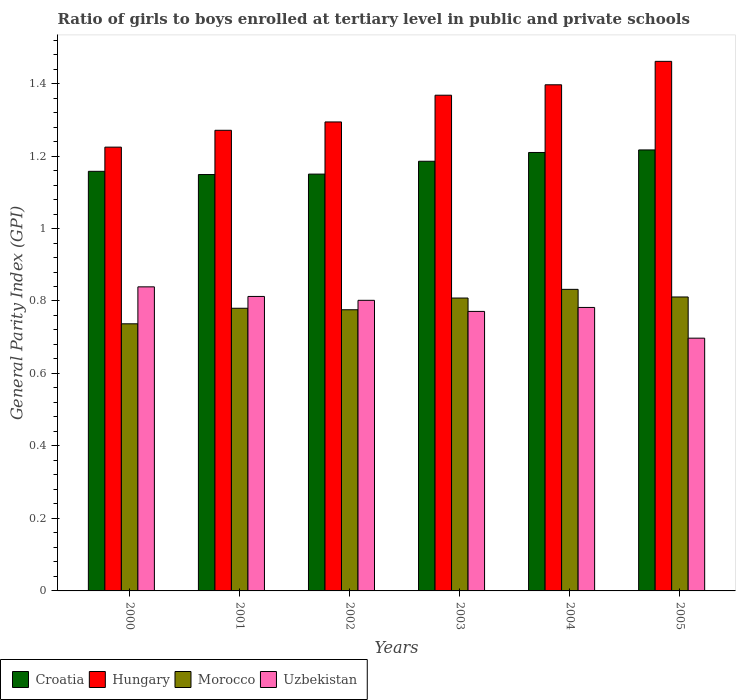How many different coloured bars are there?
Keep it short and to the point. 4. Are the number of bars per tick equal to the number of legend labels?
Ensure brevity in your answer.  Yes. Are the number of bars on each tick of the X-axis equal?
Give a very brief answer. Yes. How many bars are there on the 3rd tick from the left?
Your answer should be compact. 4. What is the label of the 2nd group of bars from the left?
Your response must be concise. 2001. In how many cases, is the number of bars for a given year not equal to the number of legend labels?
Your answer should be compact. 0. What is the general parity index in Croatia in 2002?
Keep it short and to the point. 1.15. Across all years, what is the maximum general parity index in Croatia?
Provide a short and direct response. 1.22. Across all years, what is the minimum general parity index in Uzbekistan?
Your response must be concise. 0.7. What is the total general parity index in Uzbekistan in the graph?
Keep it short and to the point. 4.7. What is the difference between the general parity index in Croatia in 2000 and that in 2003?
Your answer should be compact. -0.03. What is the difference between the general parity index in Hungary in 2000 and the general parity index in Croatia in 2003?
Give a very brief answer. 0.04. What is the average general parity index in Hungary per year?
Make the answer very short. 1.34. In the year 2003, what is the difference between the general parity index in Morocco and general parity index in Uzbekistan?
Provide a succinct answer. 0.04. What is the ratio of the general parity index in Croatia in 2001 to that in 2005?
Give a very brief answer. 0.94. Is the general parity index in Hungary in 2000 less than that in 2002?
Your answer should be very brief. Yes. What is the difference between the highest and the second highest general parity index in Croatia?
Keep it short and to the point. 0.01. What is the difference between the highest and the lowest general parity index in Morocco?
Make the answer very short. 0.1. What does the 3rd bar from the left in 2004 represents?
Offer a terse response. Morocco. What does the 4th bar from the right in 2004 represents?
Provide a short and direct response. Croatia. How many bars are there?
Offer a very short reply. 24. Are all the bars in the graph horizontal?
Keep it short and to the point. No. What is the difference between two consecutive major ticks on the Y-axis?
Your response must be concise. 0.2. Are the values on the major ticks of Y-axis written in scientific E-notation?
Keep it short and to the point. No. Does the graph contain any zero values?
Provide a succinct answer. No. Where does the legend appear in the graph?
Offer a terse response. Bottom left. How many legend labels are there?
Make the answer very short. 4. What is the title of the graph?
Offer a very short reply. Ratio of girls to boys enrolled at tertiary level in public and private schools. What is the label or title of the X-axis?
Keep it short and to the point. Years. What is the label or title of the Y-axis?
Give a very brief answer. General Parity Index (GPI). What is the General Parity Index (GPI) in Croatia in 2000?
Your answer should be very brief. 1.16. What is the General Parity Index (GPI) in Hungary in 2000?
Your answer should be compact. 1.22. What is the General Parity Index (GPI) of Morocco in 2000?
Make the answer very short. 0.74. What is the General Parity Index (GPI) in Uzbekistan in 2000?
Your answer should be compact. 0.84. What is the General Parity Index (GPI) of Croatia in 2001?
Keep it short and to the point. 1.15. What is the General Parity Index (GPI) of Hungary in 2001?
Provide a short and direct response. 1.27. What is the General Parity Index (GPI) of Morocco in 2001?
Make the answer very short. 0.78. What is the General Parity Index (GPI) in Uzbekistan in 2001?
Your answer should be very brief. 0.81. What is the General Parity Index (GPI) in Croatia in 2002?
Offer a very short reply. 1.15. What is the General Parity Index (GPI) in Hungary in 2002?
Make the answer very short. 1.29. What is the General Parity Index (GPI) in Morocco in 2002?
Give a very brief answer. 0.78. What is the General Parity Index (GPI) of Uzbekistan in 2002?
Provide a succinct answer. 0.8. What is the General Parity Index (GPI) of Croatia in 2003?
Your answer should be compact. 1.19. What is the General Parity Index (GPI) in Hungary in 2003?
Keep it short and to the point. 1.37. What is the General Parity Index (GPI) in Morocco in 2003?
Give a very brief answer. 0.81. What is the General Parity Index (GPI) of Uzbekistan in 2003?
Your response must be concise. 0.77. What is the General Parity Index (GPI) of Croatia in 2004?
Ensure brevity in your answer.  1.21. What is the General Parity Index (GPI) in Hungary in 2004?
Your answer should be compact. 1.4. What is the General Parity Index (GPI) in Morocco in 2004?
Make the answer very short. 0.83. What is the General Parity Index (GPI) of Uzbekistan in 2004?
Make the answer very short. 0.78. What is the General Parity Index (GPI) in Croatia in 2005?
Your answer should be compact. 1.22. What is the General Parity Index (GPI) in Hungary in 2005?
Your answer should be compact. 1.46. What is the General Parity Index (GPI) of Morocco in 2005?
Your response must be concise. 0.81. What is the General Parity Index (GPI) of Uzbekistan in 2005?
Your answer should be very brief. 0.7. Across all years, what is the maximum General Parity Index (GPI) of Croatia?
Provide a short and direct response. 1.22. Across all years, what is the maximum General Parity Index (GPI) in Hungary?
Provide a succinct answer. 1.46. Across all years, what is the maximum General Parity Index (GPI) of Morocco?
Provide a short and direct response. 0.83. Across all years, what is the maximum General Parity Index (GPI) of Uzbekistan?
Offer a terse response. 0.84. Across all years, what is the minimum General Parity Index (GPI) of Croatia?
Your response must be concise. 1.15. Across all years, what is the minimum General Parity Index (GPI) of Hungary?
Your answer should be very brief. 1.22. Across all years, what is the minimum General Parity Index (GPI) of Morocco?
Your answer should be compact. 0.74. Across all years, what is the minimum General Parity Index (GPI) of Uzbekistan?
Give a very brief answer. 0.7. What is the total General Parity Index (GPI) of Croatia in the graph?
Keep it short and to the point. 7.07. What is the total General Parity Index (GPI) in Hungary in the graph?
Offer a terse response. 8.02. What is the total General Parity Index (GPI) in Morocco in the graph?
Offer a terse response. 4.74. What is the total General Parity Index (GPI) in Uzbekistan in the graph?
Give a very brief answer. 4.7. What is the difference between the General Parity Index (GPI) in Croatia in 2000 and that in 2001?
Your answer should be compact. 0.01. What is the difference between the General Parity Index (GPI) of Hungary in 2000 and that in 2001?
Offer a terse response. -0.05. What is the difference between the General Parity Index (GPI) of Morocco in 2000 and that in 2001?
Make the answer very short. -0.04. What is the difference between the General Parity Index (GPI) in Uzbekistan in 2000 and that in 2001?
Your answer should be compact. 0.03. What is the difference between the General Parity Index (GPI) in Croatia in 2000 and that in 2002?
Provide a short and direct response. 0.01. What is the difference between the General Parity Index (GPI) in Hungary in 2000 and that in 2002?
Provide a short and direct response. -0.07. What is the difference between the General Parity Index (GPI) of Morocco in 2000 and that in 2002?
Offer a terse response. -0.04. What is the difference between the General Parity Index (GPI) of Uzbekistan in 2000 and that in 2002?
Provide a succinct answer. 0.04. What is the difference between the General Parity Index (GPI) in Croatia in 2000 and that in 2003?
Give a very brief answer. -0.03. What is the difference between the General Parity Index (GPI) of Hungary in 2000 and that in 2003?
Your answer should be compact. -0.14. What is the difference between the General Parity Index (GPI) in Morocco in 2000 and that in 2003?
Offer a terse response. -0.07. What is the difference between the General Parity Index (GPI) of Uzbekistan in 2000 and that in 2003?
Offer a very short reply. 0.07. What is the difference between the General Parity Index (GPI) of Croatia in 2000 and that in 2004?
Offer a very short reply. -0.05. What is the difference between the General Parity Index (GPI) of Hungary in 2000 and that in 2004?
Provide a succinct answer. -0.17. What is the difference between the General Parity Index (GPI) of Morocco in 2000 and that in 2004?
Your answer should be compact. -0.1. What is the difference between the General Parity Index (GPI) in Uzbekistan in 2000 and that in 2004?
Keep it short and to the point. 0.06. What is the difference between the General Parity Index (GPI) of Croatia in 2000 and that in 2005?
Offer a very short reply. -0.06. What is the difference between the General Parity Index (GPI) in Hungary in 2000 and that in 2005?
Your answer should be compact. -0.24. What is the difference between the General Parity Index (GPI) in Morocco in 2000 and that in 2005?
Your response must be concise. -0.07. What is the difference between the General Parity Index (GPI) in Uzbekistan in 2000 and that in 2005?
Offer a very short reply. 0.14. What is the difference between the General Parity Index (GPI) of Croatia in 2001 and that in 2002?
Offer a terse response. -0. What is the difference between the General Parity Index (GPI) of Hungary in 2001 and that in 2002?
Provide a succinct answer. -0.02. What is the difference between the General Parity Index (GPI) of Morocco in 2001 and that in 2002?
Keep it short and to the point. 0. What is the difference between the General Parity Index (GPI) in Uzbekistan in 2001 and that in 2002?
Your response must be concise. 0.01. What is the difference between the General Parity Index (GPI) in Croatia in 2001 and that in 2003?
Provide a short and direct response. -0.04. What is the difference between the General Parity Index (GPI) of Hungary in 2001 and that in 2003?
Ensure brevity in your answer.  -0.1. What is the difference between the General Parity Index (GPI) of Morocco in 2001 and that in 2003?
Offer a terse response. -0.03. What is the difference between the General Parity Index (GPI) in Uzbekistan in 2001 and that in 2003?
Give a very brief answer. 0.04. What is the difference between the General Parity Index (GPI) in Croatia in 2001 and that in 2004?
Provide a succinct answer. -0.06. What is the difference between the General Parity Index (GPI) of Hungary in 2001 and that in 2004?
Give a very brief answer. -0.13. What is the difference between the General Parity Index (GPI) in Morocco in 2001 and that in 2004?
Offer a terse response. -0.05. What is the difference between the General Parity Index (GPI) of Uzbekistan in 2001 and that in 2004?
Your answer should be very brief. 0.03. What is the difference between the General Parity Index (GPI) in Croatia in 2001 and that in 2005?
Your answer should be compact. -0.07. What is the difference between the General Parity Index (GPI) of Hungary in 2001 and that in 2005?
Keep it short and to the point. -0.19. What is the difference between the General Parity Index (GPI) in Morocco in 2001 and that in 2005?
Your response must be concise. -0.03. What is the difference between the General Parity Index (GPI) of Uzbekistan in 2001 and that in 2005?
Keep it short and to the point. 0.12. What is the difference between the General Parity Index (GPI) of Croatia in 2002 and that in 2003?
Ensure brevity in your answer.  -0.04. What is the difference between the General Parity Index (GPI) of Hungary in 2002 and that in 2003?
Give a very brief answer. -0.07. What is the difference between the General Parity Index (GPI) in Morocco in 2002 and that in 2003?
Keep it short and to the point. -0.03. What is the difference between the General Parity Index (GPI) of Uzbekistan in 2002 and that in 2003?
Your response must be concise. 0.03. What is the difference between the General Parity Index (GPI) in Croatia in 2002 and that in 2004?
Your response must be concise. -0.06. What is the difference between the General Parity Index (GPI) in Hungary in 2002 and that in 2004?
Keep it short and to the point. -0.1. What is the difference between the General Parity Index (GPI) of Morocco in 2002 and that in 2004?
Offer a terse response. -0.06. What is the difference between the General Parity Index (GPI) of Uzbekistan in 2002 and that in 2004?
Offer a very short reply. 0.02. What is the difference between the General Parity Index (GPI) in Croatia in 2002 and that in 2005?
Keep it short and to the point. -0.07. What is the difference between the General Parity Index (GPI) of Hungary in 2002 and that in 2005?
Your answer should be compact. -0.17. What is the difference between the General Parity Index (GPI) of Morocco in 2002 and that in 2005?
Provide a short and direct response. -0.04. What is the difference between the General Parity Index (GPI) in Uzbekistan in 2002 and that in 2005?
Offer a terse response. 0.1. What is the difference between the General Parity Index (GPI) in Croatia in 2003 and that in 2004?
Your answer should be compact. -0.02. What is the difference between the General Parity Index (GPI) of Hungary in 2003 and that in 2004?
Make the answer very short. -0.03. What is the difference between the General Parity Index (GPI) of Morocco in 2003 and that in 2004?
Give a very brief answer. -0.02. What is the difference between the General Parity Index (GPI) of Uzbekistan in 2003 and that in 2004?
Make the answer very short. -0.01. What is the difference between the General Parity Index (GPI) in Croatia in 2003 and that in 2005?
Your answer should be compact. -0.03. What is the difference between the General Parity Index (GPI) of Hungary in 2003 and that in 2005?
Offer a very short reply. -0.09. What is the difference between the General Parity Index (GPI) of Morocco in 2003 and that in 2005?
Offer a terse response. -0. What is the difference between the General Parity Index (GPI) of Uzbekistan in 2003 and that in 2005?
Your answer should be very brief. 0.07. What is the difference between the General Parity Index (GPI) in Croatia in 2004 and that in 2005?
Your answer should be very brief. -0.01. What is the difference between the General Parity Index (GPI) in Hungary in 2004 and that in 2005?
Your answer should be compact. -0.06. What is the difference between the General Parity Index (GPI) of Morocco in 2004 and that in 2005?
Keep it short and to the point. 0.02. What is the difference between the General Parity Index (GPI) in Uzbekistan in 2004 and that in 2005?
Provide a succinct answer. 0.08. What is the difference between the General Parity Index (GPI) of Croatia in 2000 and the General Parity Index (GPI) of Hungary in 2001?
Your answer should be compact. -0.11. What is the difference between the General Parity Index (GPI) of Croatia in 2000 and the General Parity Index (GPI) of Morocco in 2001?
Make the answer very short. 0.38. What is the difference between the General Parity Index (GPI) in Croatia in 2000 and the General Parity Index (GPI) in Uzbekistan in 2001?
Offer a very short reply. 0.35. What is the difference between the General Parity Index (GPI) of Hungary in 2000 and the General Parity Index (GPI) of Morocco in 2001?
Ensure brevity in your answer.  0.44. What is the difference between the General Parity Index (GPI) in Hungary in 2000 and the General Parity Index (GPI) in Uzbekistan in 2001?
Make the answer very short. 0.41. What is the difference between the General Parity Index (GPI) in Morocco in 2000 and the General Parity Index (GPI) in Uzbekistan in 2001?
Your response must be concise. -0.08. What is the difference between the General Parity Index (GPI) in Croatia in 2000 and the General Parity Index (GPI) in Hungary in 2002?
Provide a short and direct response. -0.14. What is the difference between the General Parity Index (GPI) of Croatia in 2000 and the General Parity Index (GPI) of Morocco in 2002?
Provide a succinct answer. 0.38. What is the difference between the General Parity Index (GPI) of Croatia in 2000 and the General Parity Index (GPI) of Uzbekistan in 2002?
Your answer should be compact. 0.36. What is the difference between the General Parity Index (GPI) in Hungary in 2000 and the General Parity Index (GPI) in Morocco in 2002?
Keep it short and to the point. 0.45. What is the difference between the General Parity Index (GPI) in Hungary in 2000 and the General Parity Index (GPI) in Uzbekistan in 2002?
Offer a terse response. 0.42. What is the difference between the General Parity Index (GPI) of Morocco in 2000 and the General Parity Index (GPI) of Uzbekistan in 2002?
Ensure brevity in your answer.  -0.06. What is the difference between the General Parity Index (GPI) of Croatia in 2000 and the General Parity Index (GPI) of Hungary in 2003?
Provide a short and direct response. -0.21. What is the difference between the General Parity Index (GPI) of Croatia in 2000 and the General Parity Index (GPI) of Morocco in 2003?
Keep it short and to the point. 0.35. What is the difference between the General Parity Index (GPI) of Croatia in 2000 and the General Parity Index (GPI) of Uzbekistan in 2003?
Keep it short and to the point. 0.39. What is the difference between the General Parity Index (GPI) of Hungary in 2000 and the General Parity Index (GPI) of Morocco in 2003?
Give a very brief answer. 0.42. What is the difference between the General Parity Index (GPI) in Hungary in 2000 and the General Parity Index (GPI) in Uzbekistan in 2003?
Make the answer very short. 0.45. What is the difference between the General Parity Index (GPI) in Morocco in 2000 and the General Parity Index (GPI) in Uzbekistan in 2003?
Keep it short and to the point. -0.03. What is the difference between the General Parity Index (GPI) of Croatia in 2000 and the General Parity Index (GPI) of Hungary in 2004?
Keep it short and to the point. -0.24. What is the difference between the General Parity Index (GPI) of Croatia in 2000 and the General Parity Index (GPI) of Morocco in 2004?
Give a very brief answer. 0.33. What is the difference between the General Parity Index (GPI) of Croatia in 2000 and the General Parity Index (GPI) of Uzbekistan in 2004?
Give a very brief answer. 0.38. What is the difference between the General Parity Index (GPI) in Hungary in 2000 and the General Parity Index (GPI) in Morocco in 2004?
Your response must be concise. 0.39. What is the difference between the General Parity Index (GPI) in Hungary in 2000 and the General Parity Index (GPI) in Uzbekistan in 2004?
Provide a short and direct response. 0.44. What is the difference between the General Parity Index (GPI) in Morocco in 2000 and the General Parity Index (GPI) in Uzbekistan in 2004?
Provide a succinct answer. -0.05. What is the difference between the General Parity Index (GPI) in Croatia in 2000 and the General Parity Index (GPI) in Hungary in 2005?
Offer a very short reply. -0.3. What is the difference between the General Parity Index (GPI) of Croatia in 2000 and the General Parity Index (GPI) of Morocco in 2005?
Offer a terse response. 0.35. What is the difference between the General Parity Index (GPI) of Croatia in 2000 and the General Parity Index (GPI) of Uzbekistan in 2005?
Offer a terse response. 0.46. What is the difference between the General Parity Index (GPI) of Hungary in 2000 and the General Parity Index (GPI) of Morocco in 2005?
Your response must be concise. 0.41. What is the difference between the General Parity Index (GPI) in Hungary in 2000 and the General Parity Index (GPI) in Uzbekistan in 2005?
Offer a very short reply. 0.53. What is the difference between the General Parity Index (GPI) of Morocco in 2000 and the General Parity Index (GPI) of Uzbekistan in 2005?
Provide a succinct answer. 0.04. What is the difference between the General Parity Index (GPI) in Croatia in 2001 and the General Parity Index (GPI) in Hungary in 2002?
Your response must be concise. -0.15. What is the difference between the General Parity Index (GPI) in Croatia in 2001 and the General Parity Index (GPI) in Morocco in 2002?
Your answer should be compact. 0.37. What is the difference between the General Parity Index (GPI) in Croatia in 2001 and the General Parity Index (GPI) in Uzbekistan in 2002?
Offer a terse response. 0.35. What is the difference between the General Parity Index (GPI) in Hungary in 2001 and the General Parity Index (GPI) in Morocco in 2002?
Ensure brevity in your answer.  0.5. What is the difference between the General Parity Index (GPI) of Hungary in 2001 and the General Parity Index (GPI) of Uzbekistan in 2002?
Offer a very short reply. 0.47. What is the difference between the General Parity Index (GPI) of Morocco in 2001 and the General Parity Index (GPI) of Uzbekistan in 2002?
Offer a terse response. -0.02. What is the difference between the General Parity Index (GPI) of Croatia in 2001 and the General Parity Index (GPI) of Hungary in 2003?
Offer a terse response. -0.22. What is the difference between the General Parity Index (GPI) in Croatia in 2001 and the General Parity Index (GPI) in Morocco in 2003?
Make the answer very short. 0.34. What is the difference between the General Parity Index (GPI) in Croatia in 2001 and the General Parity Index (GPI) in Uzbekistan in 2003?
Keep it short and to the point. 0.38. What is the difference between the General Parity Index (GPI) of Hungary in 2001 and the General Parity Index (GPI) of Morocco in 2003?
Provide a short and direct response. 0.46. What is the difference between the General Parity Index (GPI) in Hungary in 2001 and the General Parity Index (GPI) in Uzbekistan in 2003?
Make the answer very short. 0.5. What is the difference between the General Parity Index (GPI) in Morocco in 2001 and the General Parity Index (GPI) in Uzbekistan in 2003?
Give a very brief answer. 0.01. What is the difference between the General Parity Index (GPI) of Croatia in 2001 and the General Parity Index (GPI) of Hungary in 2004?
Give a very brief answer. -0.25. What is the difference between the General Parity Index (GPI) of Croatia in 2001 and the General Parity Index (GPI) of Morocco in 2004?
Offer a terse response. 0.32. What is the difference between the General Parity Index (GPI) in Croatia in 2001 and the General Parity Index (GPI) in Uzbekistan in 2004?
Provide a short and direct response. 0.37. What is the difference between the General Parity Index (GPI) in Hungary in 2001 and the General Parity Index (GPI) in Morocco in 2004?
Provide a short and direct response. 0.44. What is the difference between the General Parity Index (GPI) in Hungary in 2001 and the General Parity Index (GPI) in Uzbekistan in 2004?
Provide a succinct answer. 0.49. What is the difference between the General Parity Index (GPI) of Morocco in 2001 and the General Parity Index (GPI) of Uzbekistan in 2004?
Provide a succinct answer. -0. What is the difference between the General Parity Index (GPI) of Croatia in 2001 and the General Parity Index (GPI) of Hungary in 2005?
Your answer should be very brief. -0.31. What is the difference between the General Parity Index (GPI) of Croatia in 2001 and the General Parity Index (GPI) of Morocco in 2005?
Provide a succinct answer. 0.34. What is the difference between the General Parity Index (GPI) in Croatia in 2001 and the General Parity Index (GPI) in Uzbekistan in 2005?
Make the answer very short. 0.45. What is the difference between the General Parity Index (GPI) of Hungary in 2001 and the General Parity Index (GPI) of Morocco in 2005?
Your response must be concise. 0.46. What is the difference between the General Parity Index (GPI) of Hungary in 2001 and the General Parity Index (GPI) of Uzbekistan in 2005?
Ensure brevity in your answer.  0.57. What is the difference between the General Parity Index (GPI) in Morocco in 2001 and the General Parity Index (GPI) in Uzbekistan in 2005?
Ensure brevity in your answer.  0.08. What is the difference between the General Parity Index (GPI) in Croatia in 2002 and the General Parity Index (GPI) in Hungary in 2003?
Your answer should be very brief. -0.22. What is the difference between the General Parity Index (GPI) in Croatia in 2002 and the General Parity Index (GPI) in Morocco in 2003?
Offer a very short reply. 0.34. What is the difference between the General Parity Index (GPI) in Croatia in 2002 and the General Parity Index (GPI) in Uzbekistan in 2003?
Provide a short and direct response. 0.38. What is the difference between the General Parity Index (GPI) in Hungary in 2002 and the General Parity Index (GPI) in Morocco in 2003?
Provide a succinct answer. 0.49. What is the difference between the General Parity Index (GPI) of Hungary in 2002 and the General Parity Index (GPI) of Uzbekistan in 2003?
Ensure brevity in your answer.  0.52. What is the difference between the General Parity Index (GPI) of Morocco in 2002 and the General Parity Index (GPI) of Uzbekistan in 2003?
Ensure brevity in your answer.  0. What is the difference between the General Parity Index (GPI) in Croatia in 2002 and the General Parity Index (GPI) in Hungary in 2004?
Your answer should be very brief. -0.25. What is the difference between the General Parity Index (GPI) in Croatia in 2002 and the General Parity Index (GPI) in Morocco in 2004?
Offer a terse response. 0.32. What is the difference between the General Parity Index (GPI) of Croatia in 2002 and the General Parity Index (GPI) of Uzbekistan in 2004?
Provide a succinct answer. 0.37. What is the difference between the General Parity Index (GPI) of Hungary in 2002 and the General Parity Index (GPI) of Morocco in 2004?
Provide a succinct answer. 0.46. What is the difference between the General Parity Index (GPI) of Hungary in 2002 and the General Parity Index (GPI) of Uzbekistan in 2004?
Offer a terse response. 0.51. What is the difference between the General Parity Index (GPI) in Morocco in 2002 and the General Parity Index (GPI) in Uzbekistan in 2004?
Ensure brevity in your answer.  -0.01. What is the difference between the General Parity Index (GPI) in Croatia in 2002 and the General Parity Index (GPI) in Hungary in 2005?
Provide a succinct answer. -0.31. What is the difference between the General Parity Index (GPI) in Croatia in 2002 and the General Parity Index (GPI) in Morocco in 2005?
Keep it short and to the point. 0.34. What is the difference between the General Parity Index (GPI) of Croatia in 2002 and the General Parity Index (GPI) of Uzbekistan in 2005?
Offer a terse response. 0.45. What is the difference between the General Parity Index (GPI) of Hungary in 2002 and the General Parity Index (GPI) of Morocco in 2005?
Give a very brief answer. 0.48. What is the difference between the General Parity Index (GPI) in Hungary in 2002 and the General Parity Index (GPI) in Uzbekistan in 2005?
Your answer should be compact. 0.6. What is the difference between the General Parity Index (GPI) of Morocco in 2002 and the General Parity Index (GPI) of Uzbekistan in 2005?
Ensure brevity in your answer.  0.08. What is the difference between the General Parity Index (GPI) in Croatia in 2003 and the General Parity Index (GPI) in Hungary in 2004?
Provide a succinct answer. -0.21. What is the difference between the General Parity Index (GPI) of Croatia in 2003 and the General Parity Index (GPI) of Morocco in 2004?
Provide a short and direct response. 0.35. What is the difference between the General Parity Index (GPI) of Croatia in 2003 and the General Parity Index (GPI) of Uzbekistan in 2004?
Make the answer very short. 0.4. What is the difference between the General Parity Index (GPI) of Hungary in 2003 and the General Parity Index (GPI) of Morocco in 2004?
Provide a succinct answer. 0.54. What is the difference between the General Parity Index (GPI) in Hungary in 2003 and the General Parity Index (GPI) in Uzbekistan in 2004?
Give a very brief answer. 0.59. What is the difference between the General Parity Index (GPI) in Morocco in 2003 and the General Parity Index (GPI) in Uzbekistan in 2004?
Offer a very short reply. 0.03. What is the difference between the General Parity Index (GPI) in Croatia in 2003 and the General Parity Index (GPI) in Hungary in 2005?
Offer a very short reply. -0.28. What is the difference between the General Parity Index (GPI) in Croatia in 2003 and the General Parity Index (GPI) in Morocco in 2005?
Provide a succinct answer. 0.37. What is the difference between the General Parity Index (GPI) in Croatia in 2003 and the General Parity Index (GPI) in Uzbekistan in 2005?
Offer a very short reply. 0.49. What is the difference between the General Parity Index (GPI) of Hungary in 2003 and the General Parity Index (GPI) of Morocco in 2005?
Keep it short and to the point. 0.56. What is the difference between the General Parity Index (GPI) of Hungary in 2003 and the General Parity Index (GPI) of Uzbekistan in 2005?
Your response must be concise. 0.67. What is the difference between the General Parity Index (GPI) of Morocco in 2003 and the General Parity Index (GPI) of Uzbekistan in 2005?
Make the answer very short. 0.11. What is the difference between the General Parity Index (GPI) of Croatia in 2004 and the General Parity Index (GPI) of Hungary in 2005?
Your answer should be very brief. -0.25. What is the difference between the General Parity Index (GPI) of Croatia in 2004 and the General Parity Index (GPI) of Morocco in 2005?
Make the answer very short. 0.4. What is the difference between the General Parity Index (GPI) of Croatia in 2004 and the General Parity Index (GPI) of Uzbekistan in 2005?
Offer a terse response. 0.51. What is the difference between the General Parity Index (GPI) of Hungary in 2004 and the General Parity Index (GPI) of Morocco in 2005?
Your answer should be very brief. 0.59. What is the difference between the General Parity Index (GPI) of Hungary in 2004 and the General Parity Index (GPI) of Uzbekistan in 2005?
Offer a terse response. 0.7. What is the difference between the General Parity Index (GPI) in Morocco in 2004 and the General Parity Index (GPI) in Uzbekistan in 2005?
Make the answer very short. 0.13. What is the average General Parity Index (GPI) of Croatia per year?
Your response must be concise. 1.18. What is the average General Parity Index (GPI) in Hungary per year?
Ensure brevity in your answer.  1.34. What is the average General Parity Index (GPI) in Morocco per year?
Offer a very short reply. 0.79. What is the average General Parity Index (GPI) in Uzbekistan per year?
Your answer should be compact. 0.78. In the year 2000, what is the difference between the General Parity Index (GPI) of Croatia and General Parity Index (GPI) of Hungary?
Give a very brief answer. -0.07. In the year 2000, what is the difference between the General Parity Index (GPI) of Croatia and General Parity Index (GPI) of Morocco?
Give a very brief answer. 0.42. In the year 2000, what is the difference between the General Parity Index (GPI) in Croatia and General Parity Index (GPI) in Uzbekistan?
Give a very brief answer. 0.32. In the year 2000, what is the difference between the General Parity Index (GPI) in Hungary and General Parity Index (GPI) in Morocco?
Your answer should be compact. 0.49. In the year 2000, what is the difference between the General Parity Index (GPI) in Hungary and General Parity Index (GPI) in Uzbekistan?
Ensure brevity in your answer.  0.39. In the year 2000, what is the difference between the General Parity Index (GPI) in Morocco and General Parity Index (GPI) in Uzbekistan?
Provide a short and direct response. -0.1. In the year 2001, what is the difference between the General Parity Index (GPI) in Croatia and General Parity Index (GPI) in Hungary?
Offer a terse response. -0.12. In the year 2001, what is the difference between the General Parity Index (GPI) of Croatia and General Parity Index (GPI) of Morocco?
Offer a very short reply. 0.37. In the year 2001, what is the difference between the General Parity Index (GPI) in Croatia and General Parity Index (GPI) in Uzbekistan?
Provide a short and direct response. 0.34. In the year 2001, what is the difference between the General Parity Index (GPI) in Hungary and General Parity Index (GPI) in Morocco?
Keep it short and to the point. 0.49. In the year 2001, what is the difference between the General Parity Index (GPI) in Hungary and General Parity Index (GPI) in Uzbekistan?
Offer a terse response. 0.46. In the year 2001, what is the difference between the General Parity Index (GPI) of Morocco and General Parity Index (GPI) of Uzbekistan?
Your response must be concise. -0.03. In the year 2002, what is the difference between the General Parity Index (GPI) of Croatia and General Parity Index (GPI) of Hungary?
Ensure brevity in your answer.  -0.14. In the year 2002, what is the difference between the General Parity Index (GPI) of Croatia and General Parity Index (GPI) of Morocco?
Keep it short and to the point. 0.37. In the year 2002, what is the difference between the General Parity Index (GPI) in Croatia and General Parity Index (GPI) in Uzbekistan?
Keep it short and to the point. 0.35. In the year 2002, what is the difference between the General Parity Index (GPI) in Hungary and General Parity Index (GPI) in Morocco?
Offer a very short reply. 0.52. In the year 2002, what is the difference between the General Parity Index (GPI) in Hungary and General Parity Index (GPI) in Uzbekistan?
Your answer should be very brief. 0.49. In the year 2002, what is the difference between the General Parity Index (GPI) of Morocco and General Parity Index (GPI) of Uzbekistan?
Your answer should be compact. -0.03. In the year 2003, what is the difference between the General Parity Index (GPI) in Croatia and General Parity Index (GPI) in Hungary?
Your response must be concise. -0.18. In the year 2003, what is the difference between the General Parity Index (GPI) in Croatia and General Parity Index (GPI) in Morocco?
Provide a succinct answer. 0.38. In the year 2003, what is the difference between the General Parity Index (GPI) in Croatia and General Parity Index (GPI) in Uzbekistan?
Ensure brevity in your answer.  0.41. In the year 2003, what is the difference between the General Parity Index (GPI) of Hungary and General Parity Index (GPI) of Morocco?
Offer a very short reply. 0.56. In the year 2003, what is the difference between the General Parity Index (GPI) of Hungary and General Parity Index (GPI) of Uzbekistan?
Give a very brief answer. 0.6. In the year 2003, what is the difference between the General Parity Index (GPI) in Morocco and General Parity Index (GPI) in Uzbekistan?
Keep it short and to the point. 0.04. In the year 2004, what is the difference between the General Parity Index (GPI) of Croatia and General Parity Index (GPI) of Hungary?
Ensure brevity in your answer.  -0.19. In the year 2004, what is the difference between the General Parity Index (GPI) of Croatia and General Parity Index (GPI) of Morocco?
Your answer should be very brief. 0.38. In the year 2004, what is the difference between the General Parity Index (GPI) in Croatia and General Parity Index (GPI) in Uzbekistan?
Give a very brief answer. 0.43. In the year 2004, what is the difference between the General Parity Index (GPI) of Hungary and General Parity Index (GPI) of Morocco?
Your response must be concise. 0.56. In the year 2004, what is the difference between the General Parity Index (GPI) of Hungary and General Parity Index (GPI) of Uzbekistan?
Your answer should be compact. 0.61. In the year 2005, what is the difference between the General Parity Index (GPI) in Croatia and General Parity Index (GPI) in Hungary?
Your response must be concise. -0.24. In the year 2005, what is the difference between the General Parity Index (GPI) in Croatia and General Parity Index (GPI) in Morocco?
Make the answer very short. 0.41. In the year 2005, what is the difference between the General Parity Index (GPI) of Croatia and General Parity Index (GPI) of Uzbekistan?
Give a very brief answer. 0.52. In the year 2005, what is the difference between the General Parity Index (GPI) of Hungary and General Parity Index (GPI) of Morocco?
Give a very brief answer. 0.65. In the year 2005, what is the difference between the General Parity Index (GPI) of Hungary and General Parity Index (GPI) of Uzbekistan?
Make the answer very short. 0.76. In the year 2005, what is the difference between the General Parity Index (GPI) in Morocco and General Parity Index (GPI) in Uzbekistan?
Provide a short and direct response. 0.11. What is the ratio of the General Parity Index (GPI) in Croatia in 2000 to that in 2001?
Your answer should be compact. 1.01. What is the ratio of the General Parity Index (GPI) in Hungary in 2000 to that in 2001?
Provide a succinct answer. 0.96. What is the ratio of the General Parity Index (GPI) of Morocco in 2000 to that in 2001?
Offer a terse response. 0.94. What is the ratio of the General Parity Index (GPI) of Uzbekistan in 2000 to that in 2001?
Ensure brevity in your answer.  1.03. What is the ratio of the General Parity Index (GPI) in Hungary in 2000 to that in 2002?
Offer a very short reply. 0.95. What is the ratio of the General Parity Index (GPI) of Morocco in 2000 to that in 2002?
Ensure brevity in your answer.  0.95. What is the ratio of the General Parity Index (GPI) in Uzbekistan in 2000 to that in 2002?
Your answer should be very brief. 1.05. What is the ratio of the General Parity Index (GPI) of Croatia in 2000 to that in 2003?
Provide a short and direct response. 0.98. What is the ratio of the General Parity Index (GPI) of Hungary in 2000 to that in 2003?
Ensure brevity in your answer.  0.9. What is the ratio of the General Parity Index (GPI) of Morocco in 2000 to that in 2003?
Provide a short and direct response. 0.91. What is the ratio of the General Parity Index (GPI) in Uzbekistan in 2000 to that in 2003?
Your answer should be very brief. 1.09. What is the ratio of the General Parity Index (GPI) in Croatia in 2000 to that in 2004?
Your response must be concise. 0.96. What is the ratio of the General Parity Index (GPI) in Hungary in 2000 to that in 2004?
Provide a succinct answer. 0.88. What is the ratio of the General Parity Index (GPI) in Morocco in 2000 to that in 2004?
Give a very brief answer. 0.89. What is the ratio of the General Parity Index (GPI) in Uzbekistan in 2000 to that in 2004?
Offer a very short reply. 1.07. What is the ratio of the General Parity Index (GPI) of Croatia in 2000 to that in 2005?
Provide a short and direct response. 0.95. What is the ratio of the General Parity Index (GPI) of Hungary in 2000 to that in 2005?
Offer a terse response. 0.84. What is the ratio of the General Parity Index (GPI) in Morocco in 2000 to that in 2005?
Give a very brief answer. 0.91. What is the ratio of the General Parity Index (GPI) of Uzbekistan in 2000 to that in 2005?
Your response must be concise. 1.2. What is the ratio of the General Parity Index (GPI) of Hungary in 2001 to that in 2002?
Offer a terse response. 0.98. What is the ratio of the General Parity Index (GPI) of Morocco in 2001 to that in 2002?
Provide a short and direct response. 1.01. What is the ratio of the General Parity Index (GPI) of Uzbekistan in 2001 to that in 2002?
Make the answer very short. 1.01. What is the ratio of the General Parity Index (GPI) of Croatia in 2001 to that in 2003?
Your answer should be very brief. 0.97. What is the ratio of the General Parity Index (GPI) in Hungary in 2001 to that in 2003?
Your answer should be compact. 0.93. What is the ratio of the General Parity Index (GPI) in Morocco in 2001 to that in 2003?
Give a very brief answer. 0.97. What is the ratio of the General Parity Index (GPI) in Uzbekistan in 2001 to that in 2003?
Ensure brevity in your answer.  1.05. What is the ratio of the General Parity Index (GPI) of Croatia in 2001 to that in 2004?
Make the answer very short. 0.95. What is the ratio of the General Parity Index (GPI) in Hungary in 2001 to that in 2004?
Your answer should be very brief. 0.91. What is the ratio of the General Parity Index (GPI) of Morocco in 2001 to that in 2004?
Your answer should be very brief. 0.94. What is the ratio of the General Parity Index (GPI) in Uzbekistan in 2001 to that in 2004?
Keep it short and to the point. 1.04. What is the ratio of the General Parity Index (GPI) of Croatia in 2001 to that in 2005?
Provide a short and direct response. 0.94. What is the ratio of the General Parity Index (GPI) of Hungary in 2001 to that in 2005?
Offer a terse response. 0.87. What is the ratio of the General Parity Index (GPI) in Morocco in 2001 to that in 2005?
Provide a succinct answer. 0.96. What is the ratio of the General Parity Index (GPI) in Uzbekistan in 2001 to that in 2005?
Offer a terse response. 1.17. What is the ratio of the General Parity Index (GPI) of Croatia in 2002 to that in 2003?
Ensure brevity in your answer.  0.97. What is the ratio of the General Parity Index (GPI) in Hungary in 2002 to that in 2003?
Offer a terse response. 0.95. What is the ratio of the General Parity Index (GPI) of Uzbekistan in 2002 to that in 2003?
Ensure brevity in your answer.  1.04. What is the ratio of the General Parity Index (GPI) in Croatia in 2002 to that in 2004?
Your answer should be very brief. 0.95. What is the ratio of the General Parity Index (GPI) of Hungary in 2002 to that in 2004?
Your answer should be compact. 0.93. What is the ratio of the General Parity Index (GPI) in Morocco in 2002 to that in 2004?
Make the answer very short. 0.93. What is the ratio of the General Parity Index (GPI) of Uzbekistan in 2002 to that in 2004?
Your answer should be compact. 1.03. What is the ratio of the General Parity Index (GPI) in Croatia in 2002 to that in 2005?
Make the answer very short. 0.95. What is the ratio of the General Parity Index (GPI) of Hungary in 2002 to that in 2005?
Your answer should be compact. 0.89. What is the ratio of the General Parity Index (GPI) in Morocco in 2002 to that in 2005?
Your response must be concise. 0.96. What is the ratio of the General Parity Index (GPI) in Uzbekistan in 2002 to that in 2005?
Make the answer very short. 1.15. What is the ratio of the General Parity Index (GPI) in Hungary in 2003 to that in 2004?
Your response must be concise. 0.98. What is the ratio of the General Parity Index (GPI) of Morocco in 2003 to that in 2004?
Offer a very short reply. 0.97. What is the ratio of the General Parity Index (GPI) in Uzbekistan in 2003 to that in 2004?
Make the answer very short. 0.99. What is the ratio of the General Parity Index (GPI) of Croatia in 2003 to that in 2005?
Ensure brevity in your answer.  0.97. What is the ratio of the General Parity Index (GPI) in Hungary in 2003 to that in 2005?
Provide a short and direct response. 0.94. What is the ratio of the General Parity Index (GPI) in Uzbekistan in 2003 to that in 2005?
Offer a terse response. 1.11. What is the ratio of the General Parity Index (GPI) of Croatia in 2004 to that in 2005?
Your response must be concise. 0.99. What is the ratio of the General Parity Index (GPI) of Hungary in 2004 to that in 2005?
Make the answer very short. 0.96. What is the ratio of the General Parity Index (GPI) of Morocco in 2004 to that in 2005?
Make the answer very short. 1.03. What is the ratio of the General Parity Index (GPI) of Uzbekistan in 2004 to that in 2005?
Offer a terse response. 1.12. What is the difference between the highest and the second highest General Parity Index (GPI) in Croatia?
Offer a very short reply. 0.01. What is the difference between the highest and the second highest General Parity Index (GPI) of Hungary?
Provide a short and direct response. 0.06. What is the difference between the highest and the second highest General Parity Index (GPI) in Morocco?
Keep it short and to the point. 0.02. What is the difference between the highest and the second highest General Parity Index (GPI) of Uzbekistan?
Offer a very short reply. 0.03. What is the difference between the highest and the lowest General Parity Index (GPI) in Croatia?
Your response must be concise. 0.07. What is the difference between the highest and the lowest General Parity Index (GPI) in Hungary?
Your response must be concise. 0.24. What is the difference between the highest and the lowest General Parity Index (GPI) of Morocco?
Your answer should be compact. 0.1. What is the difference between the highest and the lowest General Parity Index (GPI) in Uzbekistan?
Give a very brief answer. 0.14. 